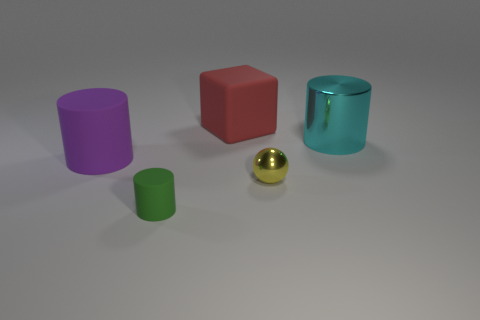Subtract all small cylinders. How many cylinders are left? 2 Subtract 1 balls. How many balls are left? 0 Add 1 big rubber cylinders. How many objects exist? 6 Subtract all balls. How many objects are left? 4 Subtract all green cylinders. How many cylinders are left? 2 Add 3 large objects. How many large objects are left? 6 Add 2 shiny objects. How many shiny objects exist? 4 Subtract 0 yellow cubes. How many objects are left? 5 Subtract all blue blocks. Subtract all cyan cylinders. How many blocks are left? 1 Subtract all blue balls. How many green cylinders are left? 1 